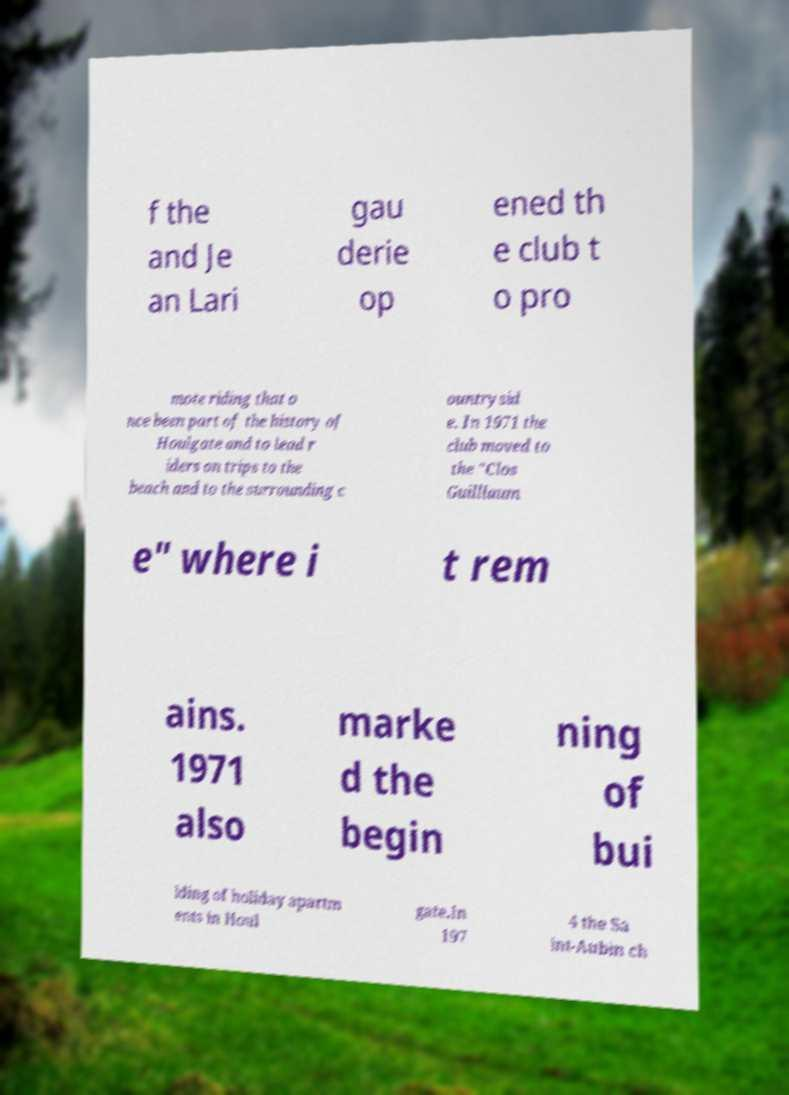For documentation purposes, I need the text within this image transcribed. Could you provide that? f the and Je an Lari gau derie op ened th e club t o pro mote riding that o nce been part of the history of Houlgate and to lead r iders on trips to the beach and to the surrounding c ountrysid e. In 1971 the club moved to the "Clos Guilllaum e" where i t rem ains. 1971 also marke d the begin ning of bui lding of holiday apartm ents in Houl gate.In 197 4 the Sa int-Aubin ch 